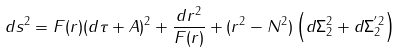<formula> <loc_0><loc_0><loc_500><loc_500>d s ^ { 2 } = F ( r ) ( d \tau + A ) ^ { 2 } + \frac { d r ^ { 2 } } { F ( r ) } + ( r ^ { 2 } - N ^ { 2 } ) \left ( d \Sigma _ { 2 } ^ { 2 } + d \Sigma _ { 2 } ^ { ^ { \prime } 2 } \right )</formula> 